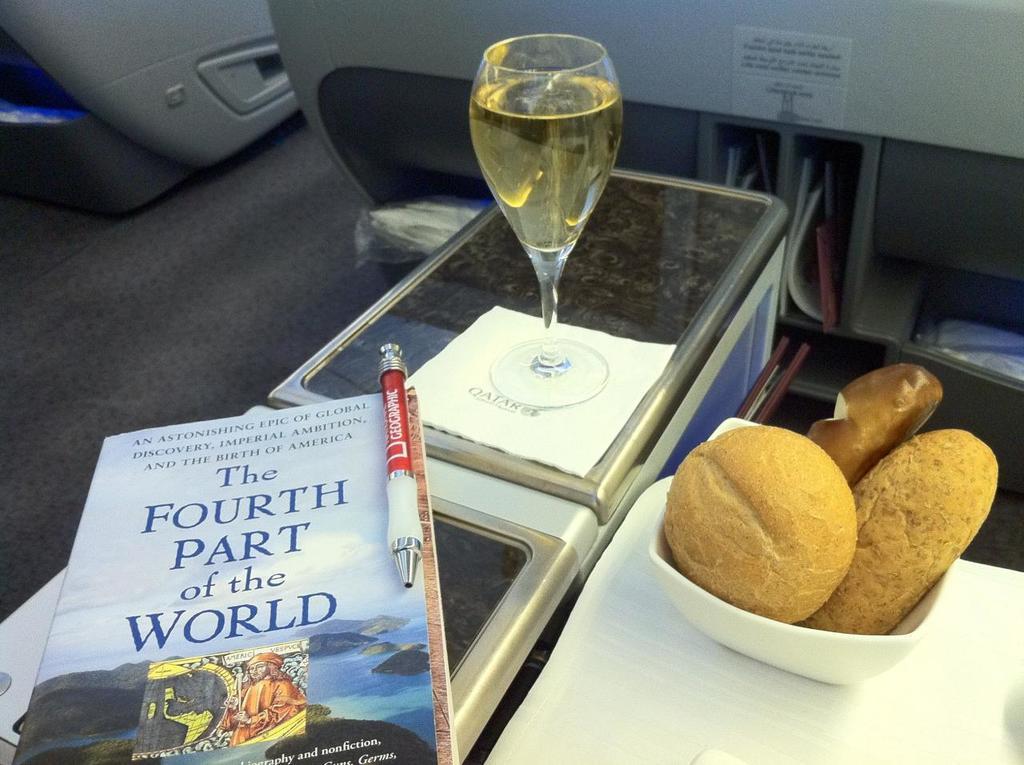What part of the world is the book talking about?
Ensure brevity in your answer.  Fourth part. What color is the pen?
Make the answer very short. Red. 